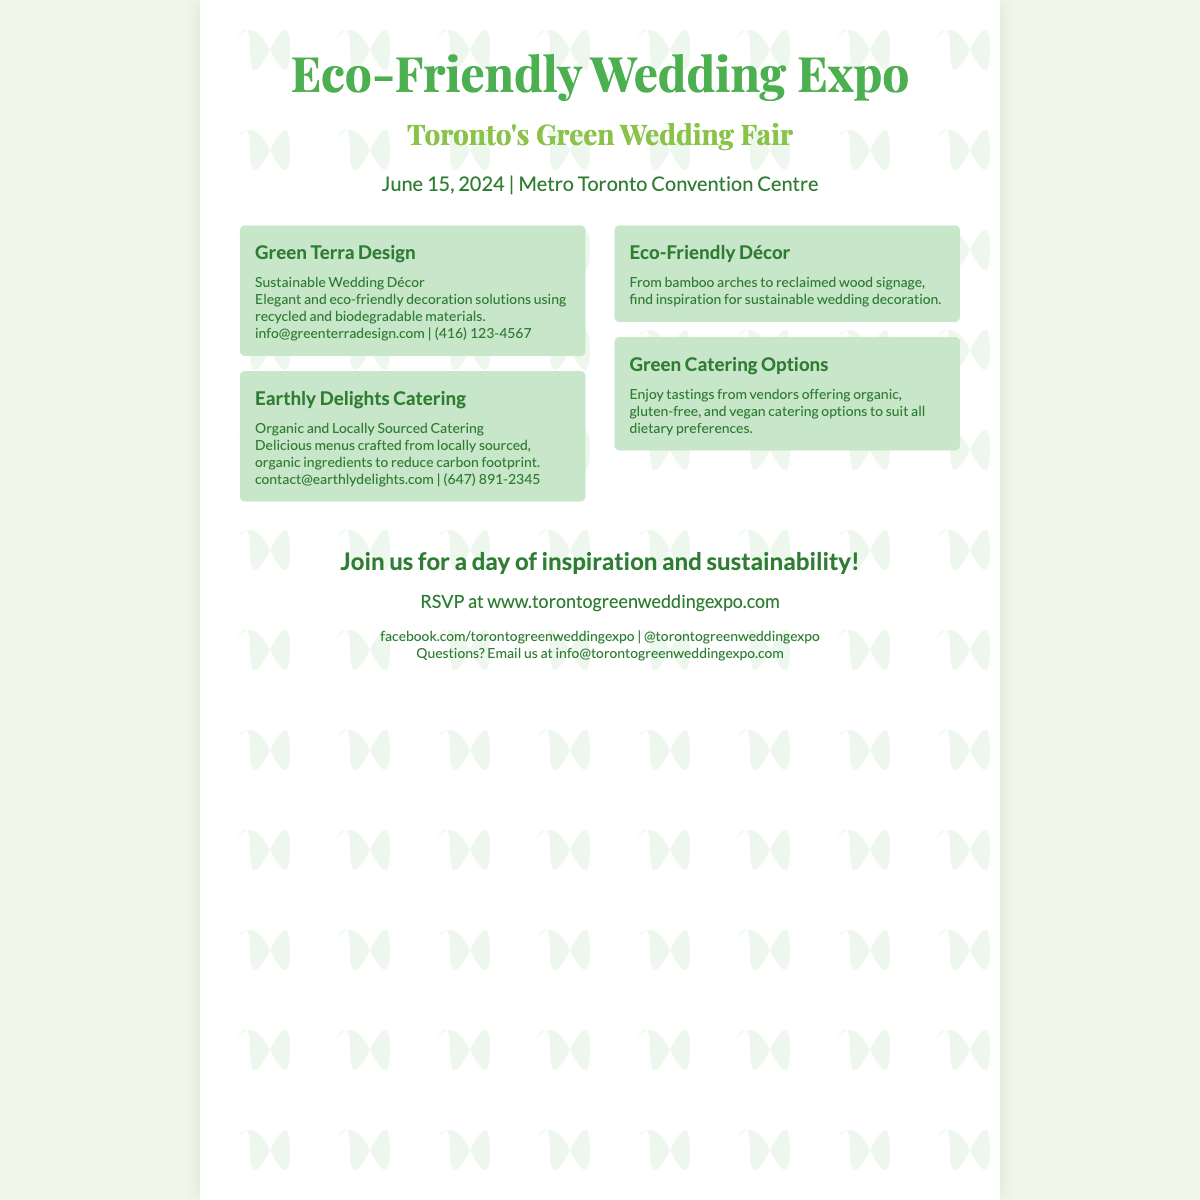What is the date of the Eco-Friendly Wedding Expo? The date is specifically mentioned in the document as June 15, 2024.
Answer: June 15, 2024 Where will the event take place? The venue is mentioned in the poster as the Metro Toronto Convention Centre.
Answer: Metro Toronto Convention Centre What type of catering does Earthly Delights Catering provide? The document specifies that they offer organic and locally sourced catering.
Answer: Organic and Locally Sourced Catering What is the name of the exhibitor that specializes in sustainable wedding décor? The document lists Green Terra Design as the exhibitor specializing in sustainable wedding décor.
Answer: Green Terra Design What is the URL for RSVP information? The RSVP link is provided in the footer of the poster.
Answer: www.torontogreenweddingexpo.com What is one feature highlighted about eco-friendly décor? The document notes that it includes bamboo arches and reclaimed wood signage.
Answer: Bamboo arches to reclaimed wood signage What is the focus of the Green Catering Options feature? The document states that it offers organic, gluten-free, and vegan catering options.
Answer: Organic, gluten-free, and vegan catering options How can attendees contact the event organizers with questions? The contact email for inquiries is provided in the footer of the poster.
Answer: info@torontogreenweddingexpo.com 